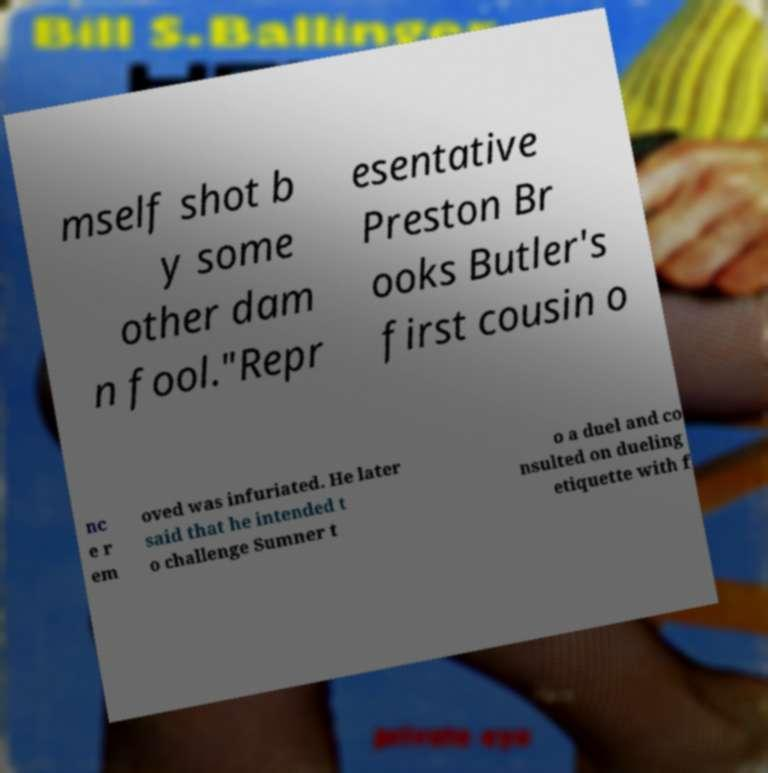Please identify and transcribe the text found in this image. mself shot b y some other dam n fool."Repr esentative Preston Br ooks Butler's first cousin o nc e r em oved was infuriated. He later said that he intended t o challenge Sumner t o a duel and co nsulted on dueling etiquette with f 